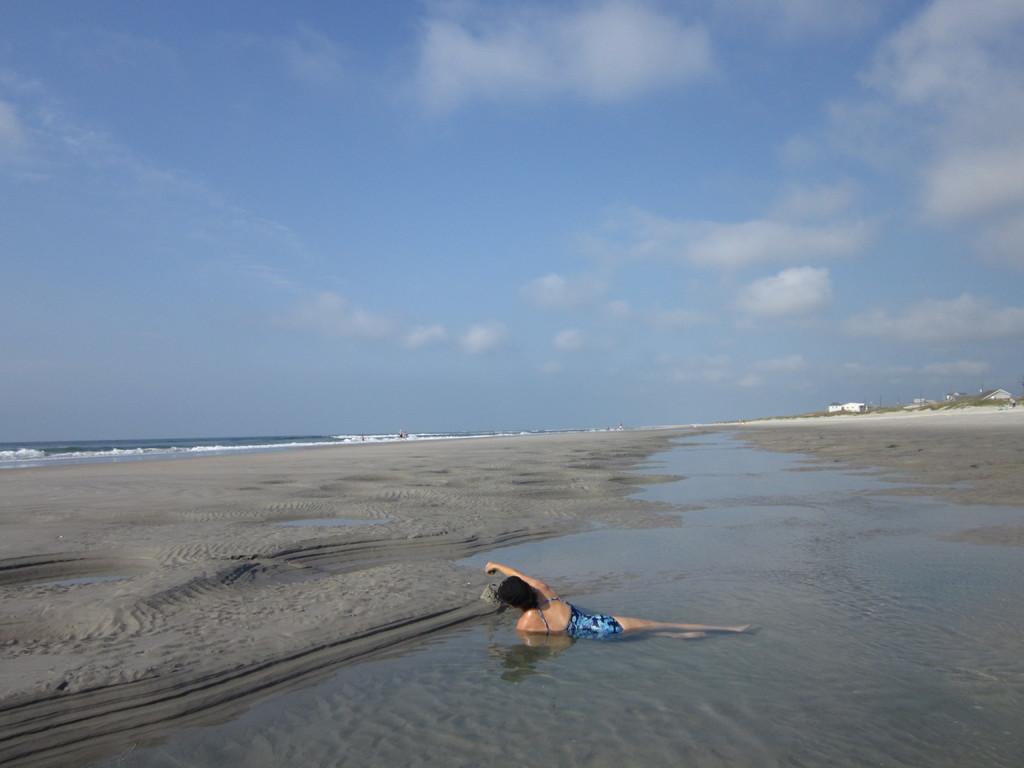Could you give a brief overview of what you see in this image? In this image in front there is a person in the water by holding the object. In front of her there is sand. In the background there is a river and sky. On the right side of the image there are buildings. 